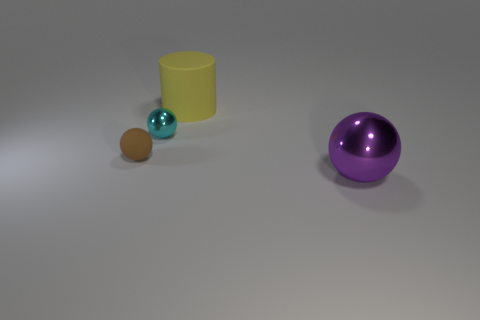Subtract all cyan balls. How many balls are left? 2 Subtract all cyan balls. How many balls are left? 2 Subtract all cylinders. How many objects are left? 3 Subtract all large matte things. Subtract all small brown rubber blocks. How many objects are left? 3 Add 4 brown things. How many brown things are left? 5 Add 4 large purple balls. How many large purple balls exist? 5 Add 3 big red metallic balls. How many objects exist? 7 Subtract 0 brown cylinders. How many objects are left? 4 Subtract 1 cylinders. How many cylinders are left? 0 Subtract all yellow balls. Subtract all yellow cylinders. How many balls are left? 3 